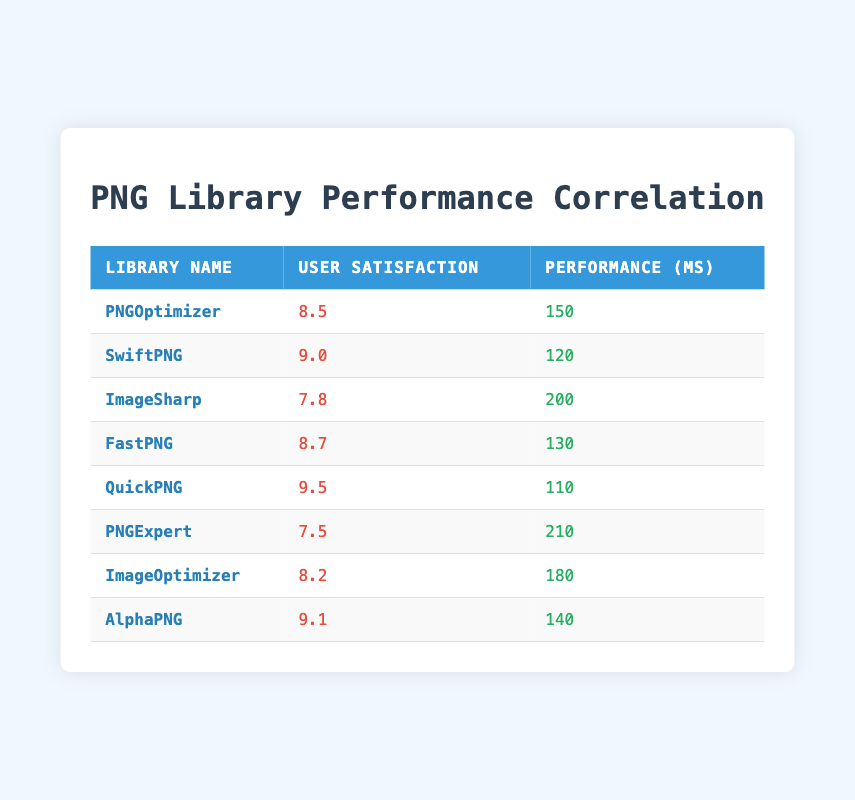What is the user satisfaction rating of QuickPNG? The user satisfaction rating of QuickPNG is listed directly in the table under the "User Satisfaction" column for that library. I can see that it is 9.5.
Answer: 9.5 Which library has the highest user satisfaction rating? By reviewing the "User Satisfaction" column in the table, QuickPNG has the highest rating at 9.5, which is greater than the ratings of all other libraries.
Answer: QuickPNG What is the average performance time of all libraries? To find the average performance time, sum all the performance values (150 + 120 + 200 + 130 + 110 + 210 + 180 + 140 = 1,340 ms) and divide by the number of libraries (8). Thus, the average performance time is 1,340/8 = 167.5 ms.
Answer: 167.5 ms Is there a correlation between user satisfaction and performance time? By examining the values, I see that libraries with higher user satisfaction ratings tend to have lower performance times. For example, QuickPNG (9.5) has the best satisfaction and a performance time of 110 ms, whereas PNGExpert (7.5) has a lower satisfaction and longer performance time of 210 ms. This suggests a negative correlation.
Answer: Yes Which library has the best performance time among those rated above 8.0 for user satisfaction? Filter the libraries where user satisfaction is greater than 8.0, which includes PNGOptimizer (150 ms), SwiftPNG (120 ms), FastPNG (130 ms), QuickPNG (110 ms), and AlphaPNG (140 ms). The lowest performance time from this subset is for QuickPNG at 110 ms.
Answer: QuickPNG How much faster is SwiftPNG compared to ImageSharp in terms of performance? To calculate the difference, subtract the performance time of ImageSharp (200 ms) from that of SwiftPNG (120 ms). Therefore, 200 - 120 = 80 ms, indicating that SwiftPNG is 80 ms faster.
Answer: 80 ms Are there any libraries that have both a user satisfaction rating above 8.0 and a performance time below 150 ms? Checking the table, both SwiftPNG (9.0, 120 ms) and FastPNG (8.7, 130 ms) meet this criterion, confirming that there are libraries fulfilling both conditions.
Answer: Yes What is the median user satisfaction rating for all libraries listed? To find the median, I first list the user satisfaction ratings in order: 7.5, 7.8, 8.2, 8.5, 8.7, 9.0, 9.1, 9.5. With an even number of values, the median is the average of the 4th and 5th values: (8.5 + 8.7)/2 = 8.6.
Answer: 8.6 